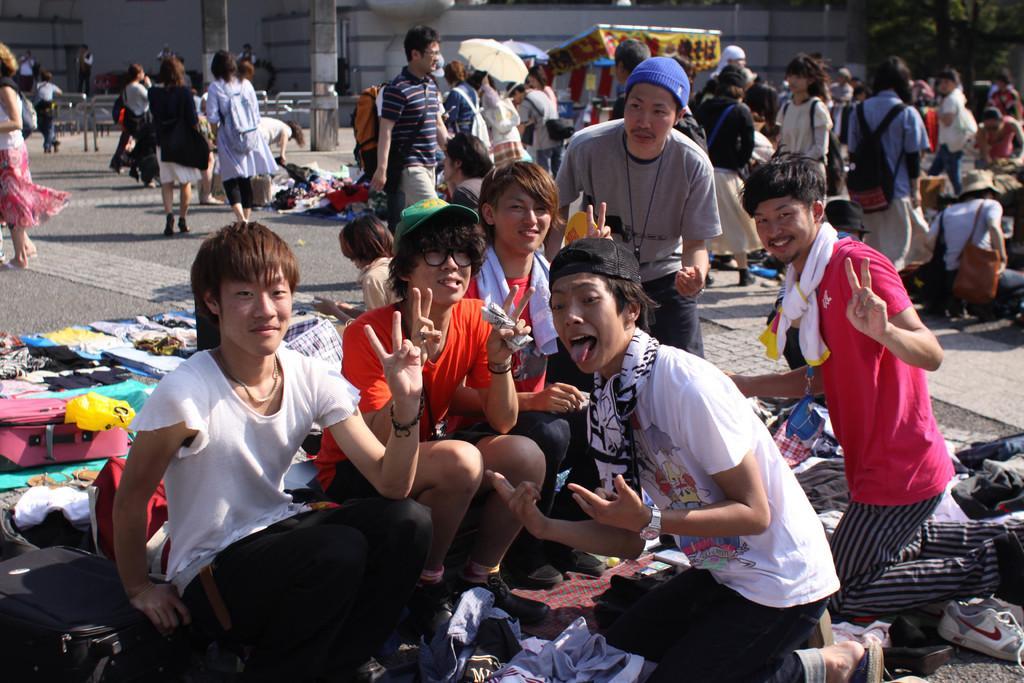Please provide a concise description of this image. As we can see in the image there are group of people here and there, cloth, suitcase and in the background there is a building. 